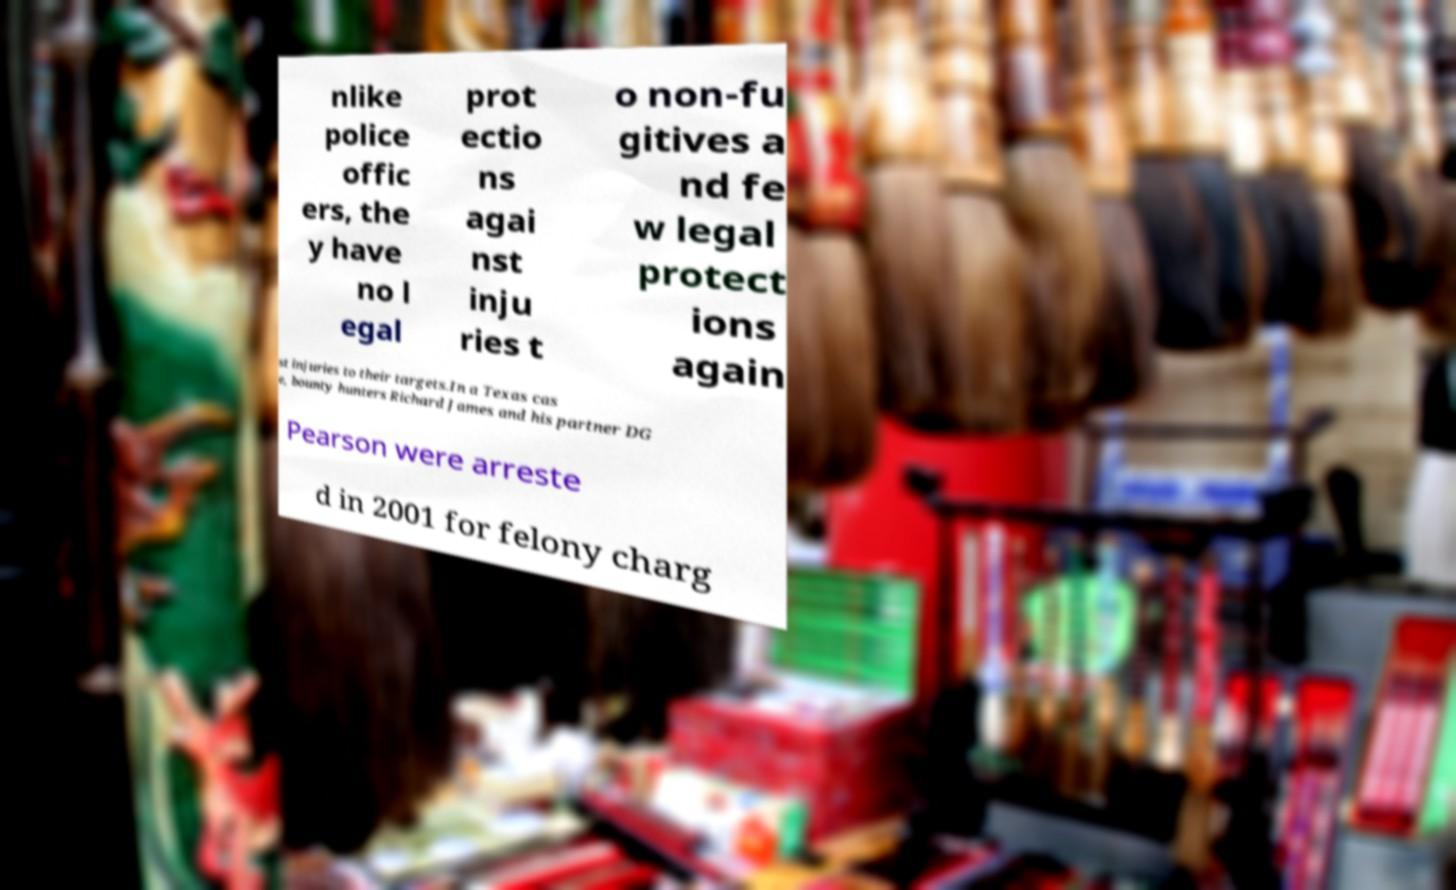Can you accurately transcribe the text from the provided image for me? nlike police offic ers, the y have no l egal prot ectio ns agai nst inju ries t o non-fu gitives a nd fe w legal protect ions again st injuries to their targets.In a Texas cas e, bounty hunters Richard James and his partner DG Pearson were arreste d in 2001 for felony charg 